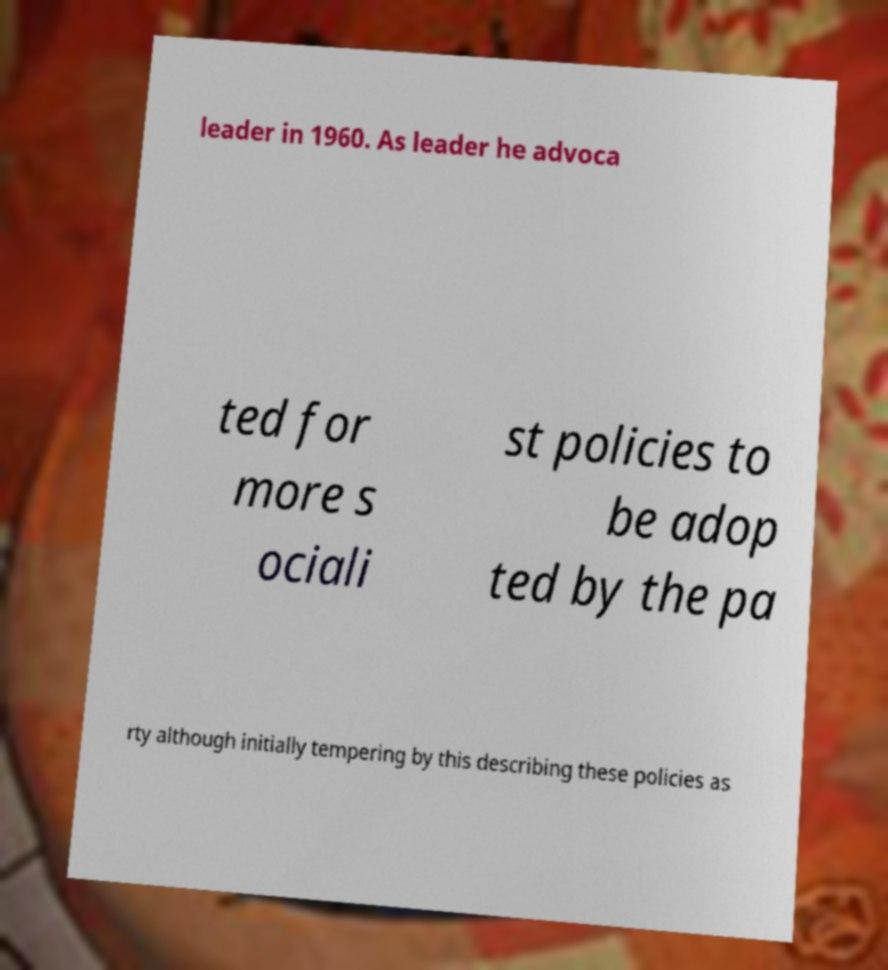What messages or text are displayed in this image? I need them in a readable, typed format. leader in 1960. As leader he advoca ted for more s ociali st policies to be adop ted by the pa rty although initially tempering by this describing these policies as 